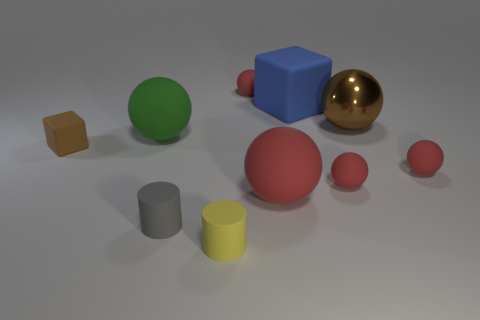Can you describe the shapes and colors of the objects in the image? Certainly! The image displays a variety of geometric shapes in different colors. There's a large red sphere, a medium-sized green sphere, and three smaller red spheres, which could likely be tiny rubber balls. A blue cube and a small brown cube appear to be solid and possibly made of plastic or wood. Additionally, we see a large reflective gold sphere, possibly metallic, and a grey cylinder next to a vibrant yellow cylinder. The objects are arranged on a flat surface with a neutral background that ensures they stand out. 